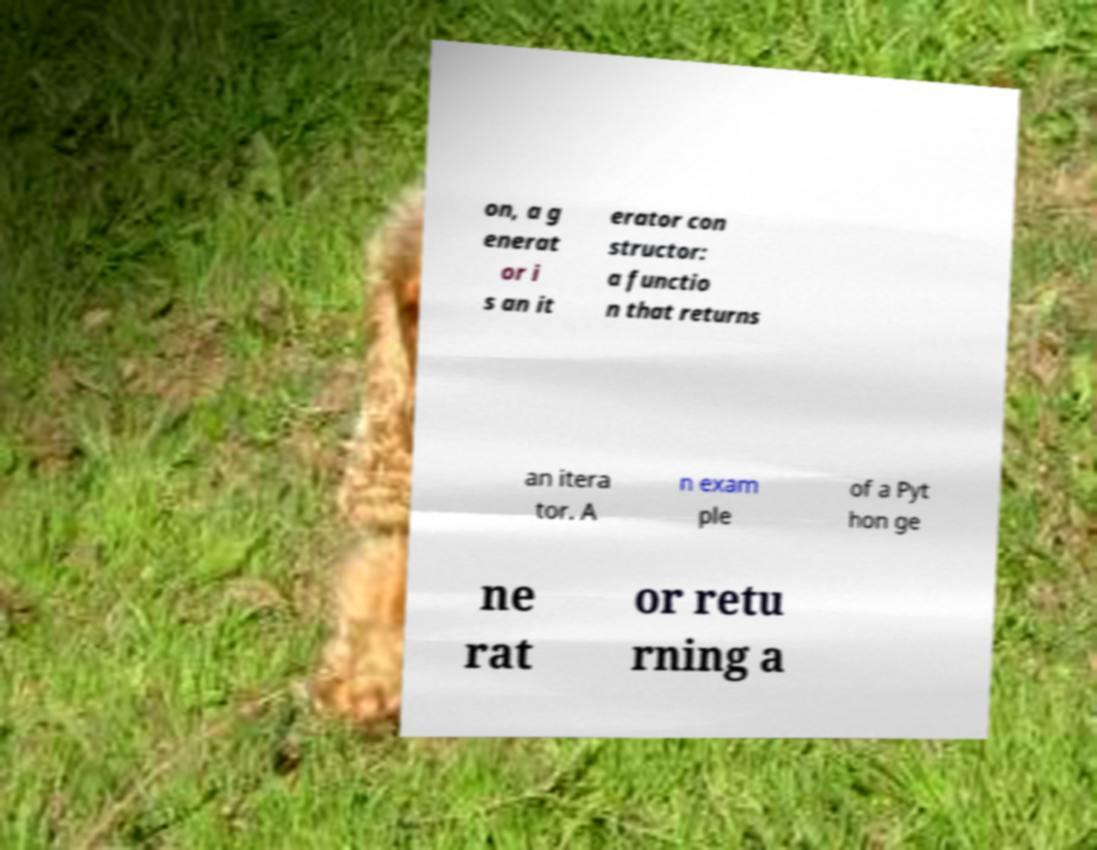For documentation purposes, I need the text within this image transcribed. Could you provide that? on, a g enerat or i s an it erator con structor: a functio n that returns an itera tor. A n exam ple of a Pyt hon ge ne rat or retu rning a 